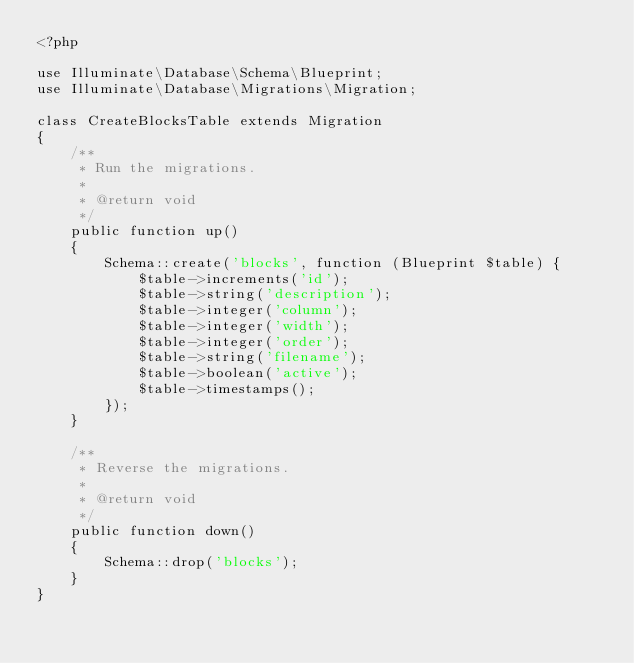<code> <loc_0><loc_0><loc_500><loc_500><_PHP_><?php

use Illuminate\Database\Schema\Blueprint;
use Illuminate\Database\Migrations\Migration;

class CreateBlocksTable extends Migration
{
    /**
     * Run the migrations.
     *
     * @return void
     */
    public function up()
    {
        Schema::create('blocks', function (Blueprint $table) {
            $table->increments('id');
            $table->string('description');
            $table->integer('column');
            $table->integer('width');
            $table->integer('order');
            $table->string('filename');
            $table->boolean('active');
            $table->timestamps();
        });
    }

    /**
     * Reverse the migrations.
     *
     * @return void
     */
    public function down()
    {
        Schema::drop('blocks');
    }
}
</code> 